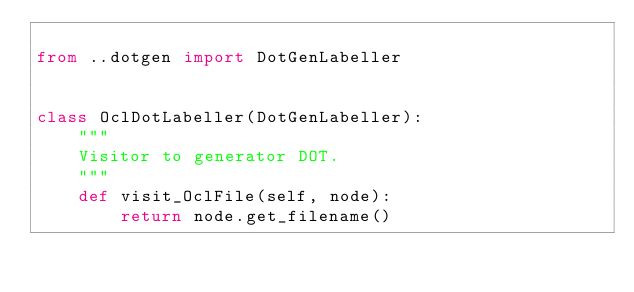<code> <loc_0><loc_0><loc_500><loc_500><_Python_>
from ..dotgen import DotGenLabeller


class OclDotLabeller(DotGenLabeller):
    """
    Visitor to generator DOT.
    """
    def visit_OclFile(self, node):
        return node.get_filename()
</code> 